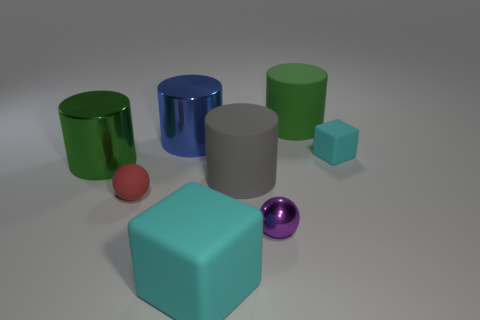How many small purple things are made of the same material as the blue cylinder?
Make the answer very short. 1. There is a red object; what number of small purple things are behind it?
Your response must be concise. 0. Do the cylinder right of the large gray cylinder and the green thing that is in front of the tiny cyan rubber block have the same material?
Your answer should be very brief. No. Is the number of large cylinders in front of the small red object greater than the number of small rubber balls on the right side of the small metallic thing?
Offer a very short reply. No. There is a small cube that is the same color as the big cube; what material is it?
Your answer should be compact. Rubber. Is there anything else that is the same shape as the tiny cyan matte thing?
Offer a very short reply. Yes. What material is the cylinder that is both on the right side of the small matte ball and in front of the blue cylinder?
Your answer should be very brief. Rubber. Is the red thing made of the same material as the block in front of the red rubber sphere?
Provide a short and direct response. Yes. Are there any other things that are the same size as the purple shiny thing?
Provide a short and direct response. Yes. What number of things are small matte cubes or tiny cyan cubes that are behind the green metallic cylinder?
Ensure brevity in your answer.  1. 